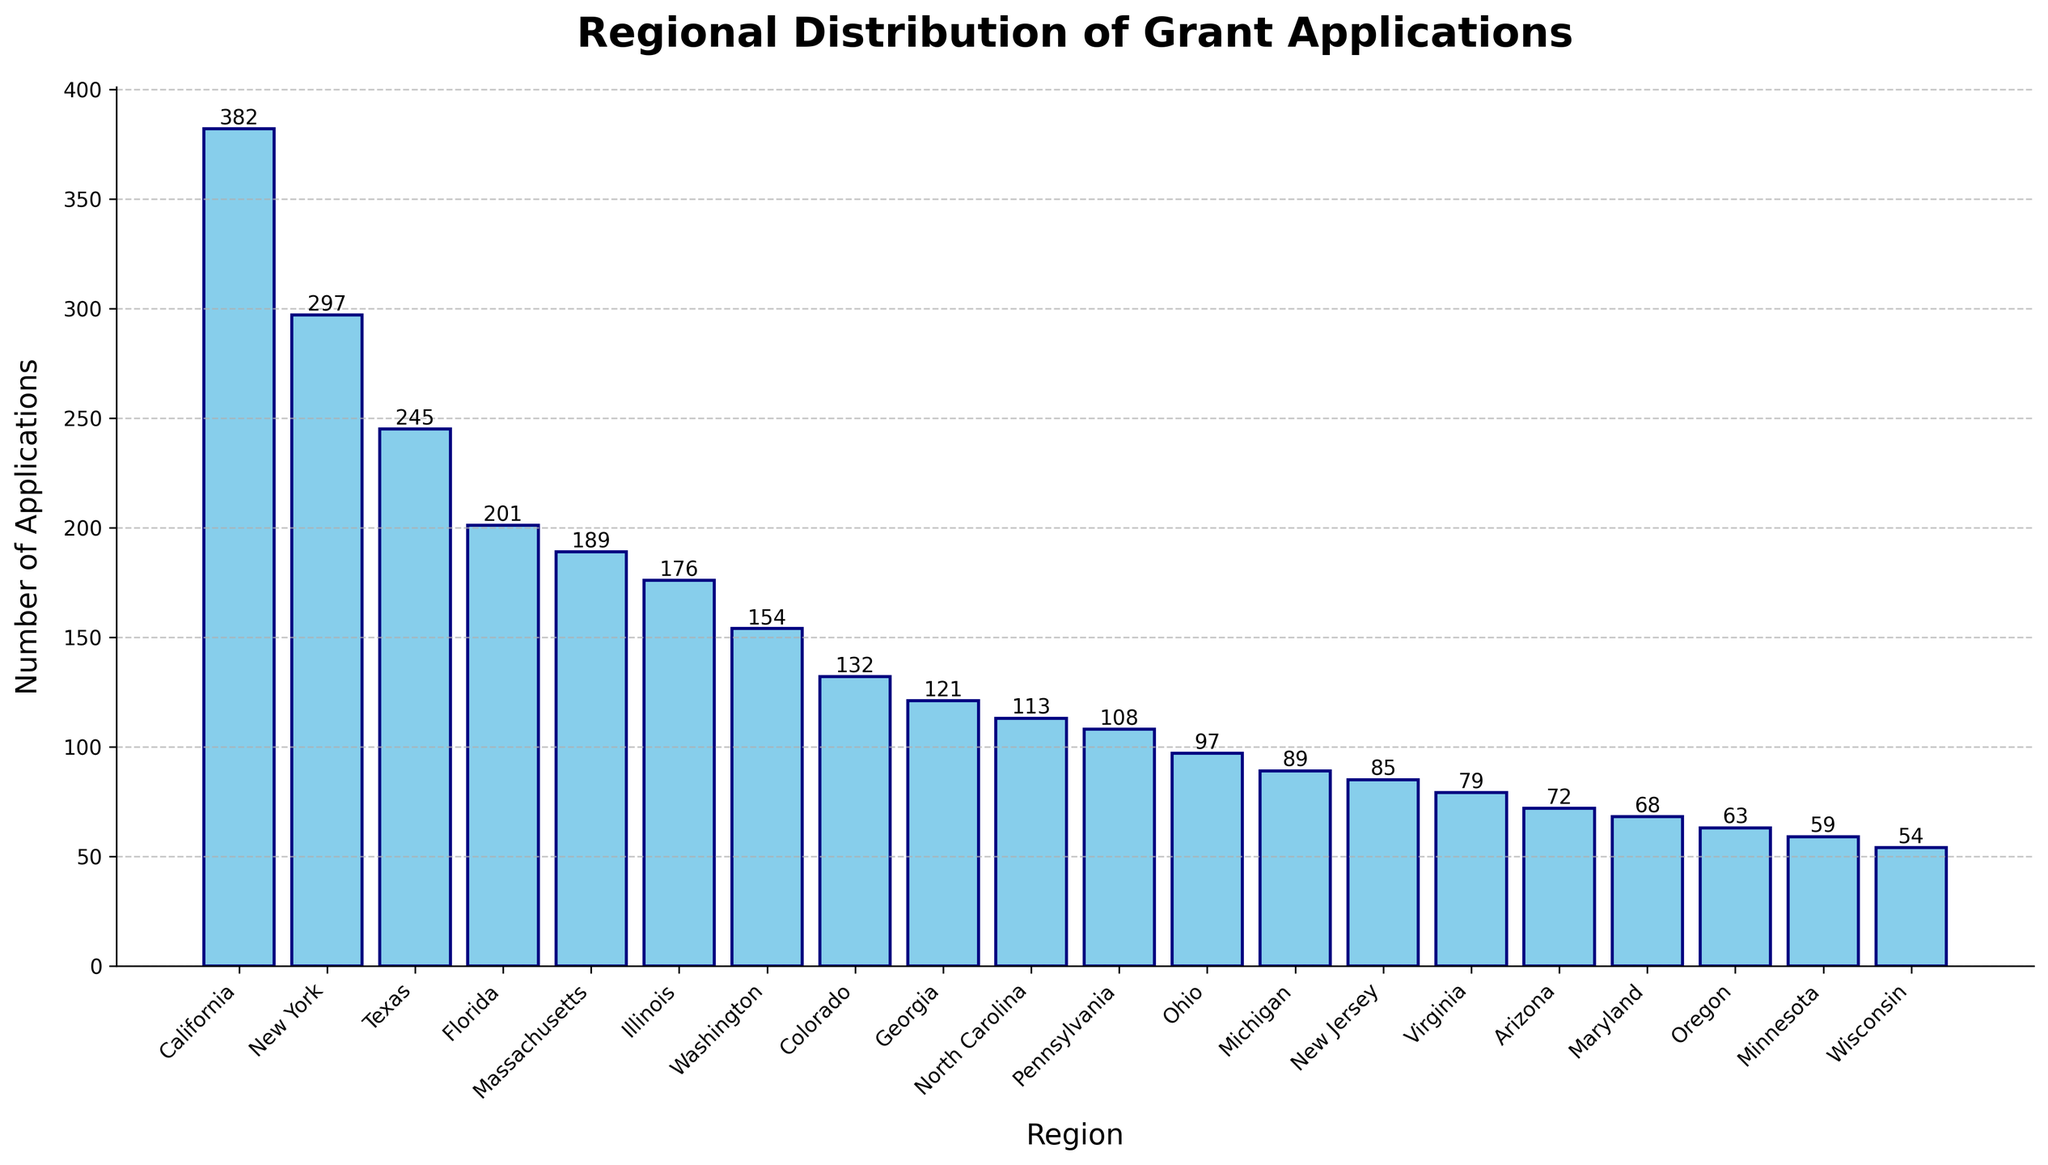Which region has the highest number of grant applications? By looking at the tallest bar, we can see that California has the highest number of grant applications with 382.
Answer: California How many more applications did New York receive compared to Florida? New York received 297 applications and Florida received 201 applications. The difference is 297 - 201 = 96.
Answer: 96 Which three regions have the fewest grant applications? By looking at the shortest bars, the three regions with the fewest applications are Wisconsin (54), Minnesota (59), and Oregon (63).
Answer: Wisconsin, Minnesota, Oregon What is the total number of applications received by Texas and Illinois? Texas received 245 applications and Illinois received 176 applications. The sum is 245 + 176 = 421.
Answer: 421 How much higher is the number of applications in Texas compared to Massachusetts? Texas has 245 applications and Massachusetts has 189 applications. The difference is 245 - 189 = 56.
Answer: 56 What's the average number of applications received by the top five regions? The top five regions and their numbers are California (382), New York (297), Texas (245), Florida (201), and Massachusetts (189). The total is 382 + 297 + 245 + 201 + 189 = 1314. The average is 1314 / 5 = 262.8.
Answer: 262.8 Which region received exactly halfway between 80 to 240 applications? Looking at the bars within the range 80 to 240, we find Virginia (79), Arizona (72), and Maryland (68) are close to midway, but Florida at 201 is the correct median number.
Answer: Florida Is the number of applications from Washington more than double that of Oregon? Washington received 154 applications, and Oregon received 63 applications. Checking if 154 > 2 * 63 or 154 > 126, which is true.
Answer: Yes What is the cumulative number of applications from the regions with more than 100 applications each? Summing applications from California (382), New York (297), Texas (245), Florida (201), Massachusetts (189), Illinois (176), Washington (154), Colorado (132), and Georgia (121), the total is 382 + 297 + 245 + 201 + 189 + 176 + 154 + 132 + 121 = 1897.
Answer: 1897 